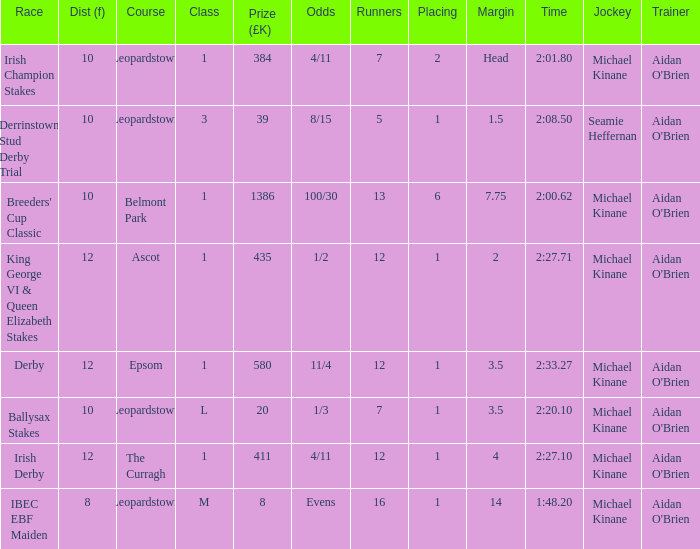Can you give me this table as a dict? {'header': ['Race', 'Dist (f)', 'Course', 'Class', 'Prize (£K)', 'Odds', 'Runners', 'Placing', 'Margin', 'Time', 'Jockey', 'Trainer'], 'rows': [['Irish Champion Stakes', '10', 'Leopardstown', '1', '384', '4/11', '7', '2', 'Head', '2:01.80', 'Michael Kinane', "Aidan O'Brien"], ['Derrinstown Stud Derby Trial', '10', 'Leopardstown', '3', '39', '8/15', '5', '1', '1.5', '2:08.50', 'Seamie Heffernan', "Aidan O'Brien"], ["Breeders' Cup Classic", '10', 'Belmont Park', '1', '1386', '100/30', '13', '6', '7.75', '2:00.62', 'Michael Kinane', "Aidan O'Brien"], ['King George VI & Queen Elizabeth Stakes', '12', 'Ascot', '1', '435', '1/2', '12', '1', '2', '2:27.71', 'Michael Kinane', "Aidan O'Brien"], ['Derby', '12', 'Epsom', '1', '580', '11/4', '12', '1', '3.5', '2:33.27', 'Michael Kinane', "Aidan O'Brien"], ['Ballysax Stakes', '10', 'Leopardstown', 'L', '20', '1/3', '7', '1', '3.5', '2:20.10', 'Michael Kinane', "Aidan O'Brien"], ['Irish Derby', '12', 'The Curragh', '1', '411', '4/11', '12', '1', '4', '2:27.10', 'Michael Kinane', "Aidan O'Brien"], ['IBEC EBF Maiden', '8', 'Leopardstown', 'M', '8', 'Evens', '16', '1', '14', '1:48.20', 'Michael Kinane', "Aidan O'Brien"]]} Which Race has a Runners of 7 and Odds of 1/3? Ballysax Stakes. 